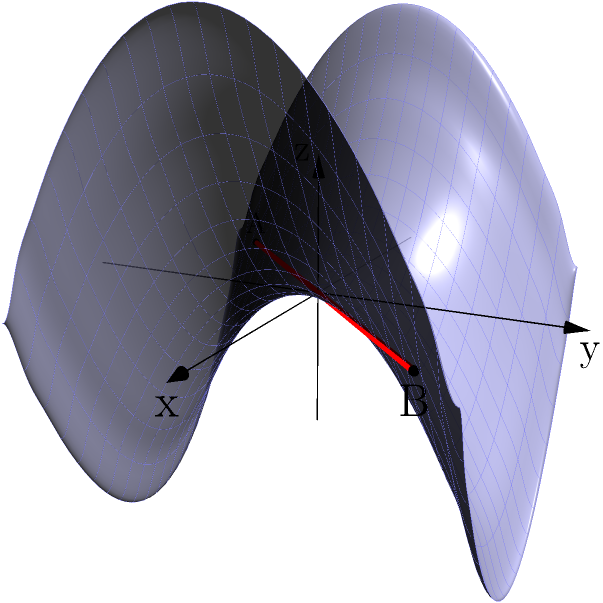On a saddle-shaped surface described by the equation $z = 0.5(x^2 - y^2)$, consider two points A(-1.5, -1.5, 0.75) and B(1.5, 1.5, 0.75). The straight line connecting these points is shown in red. Is this straight line the shortest path (geodesic) between A and B on this surface? If not, describe the general shape of the actual geodesic. To determine if the straight line is the shortest path (geodesic) between points A and B on the saddle-shaped surface, we need to consider the following:

1. The surface is described by $z = 0.5(x^2 - y^2)$, which is a hyperbolic paraboloid (saddle shape).

2. In Euclidean space, the shortest path between two points is always a straight line. However, on curved surfaces, this is not necessarily true.

3. For a hyperbolic paraboloid, the geodesics (shortest paths) are generally not straight lines when projected onto the xy-plane.

4. The straight line connecting A and B (shown in red) does not follow the curvature of the surface. It "cuts through" the air above and below the surface.

5. The actual geodesic would stay on the surface at all points, following its curvature.

6. For this specific saddle shape, the geodesic between A and B would curve away from the straight line, following a path that minimizes the distance along the surface.

7. The geodesic would likely form an S-shaped curve when projected onto the xy-plane, starting at A, curving towards the y-axis, then curving back towards B.

8. This curved path, while longer in the xy-plane, would be shorter along the surface than the straight line path.

Therefore, the straight line is not the shortest path (geodesic) between A and B on this saddle-shaped surface. The actual geodesic would be a curved path that follows the surface's contours.
Answer: No; S-shaped curve following surface contours 